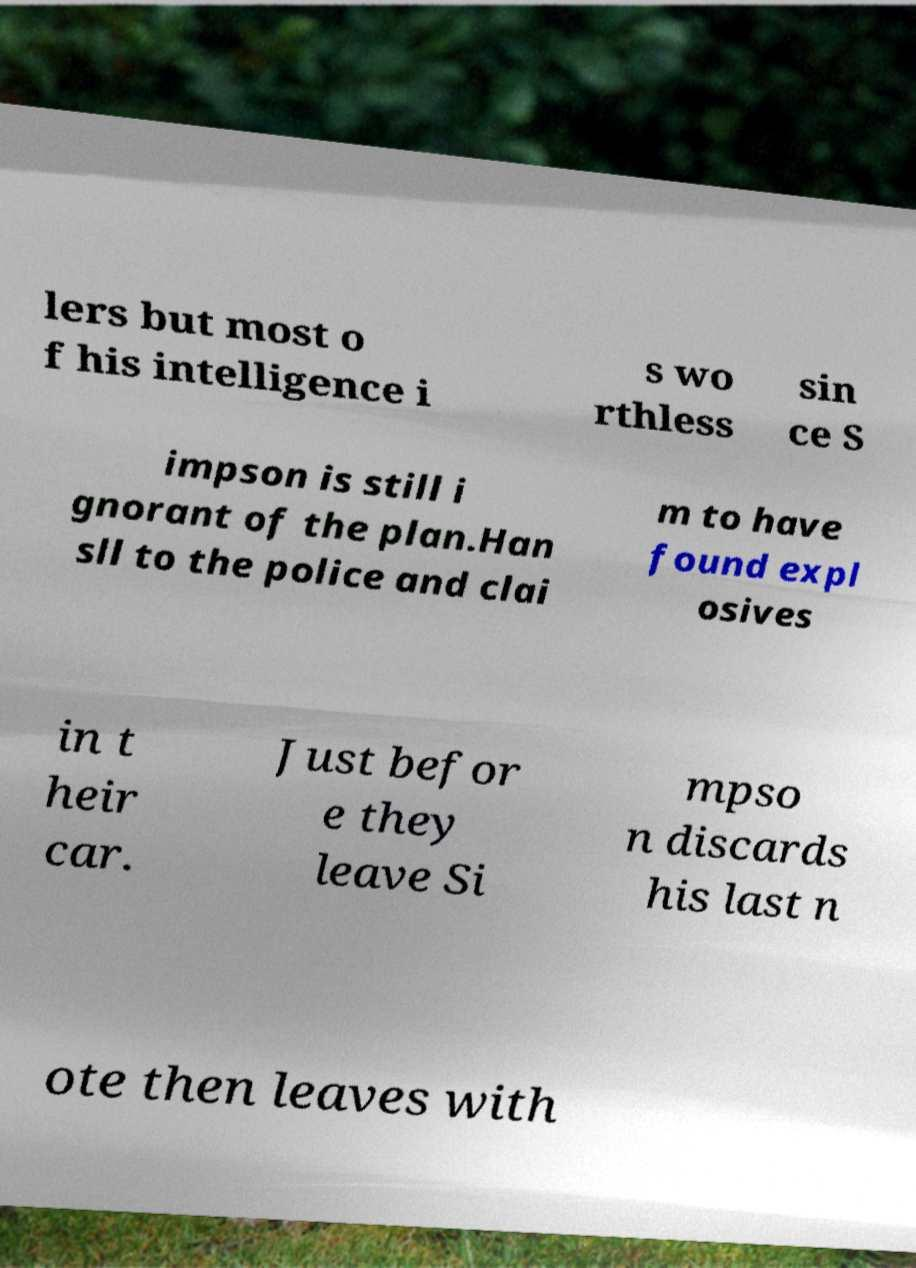I need the written content from this picture converted into text. Can you do that? lers but most o f his intelligence i s wo rthless sin ce S impson is still i gnorant of the plan.Han sll to the police and clai m to have found expl osives in t heir car. Just befor e they leave Si mpso n discards his last n ote then leaves with 